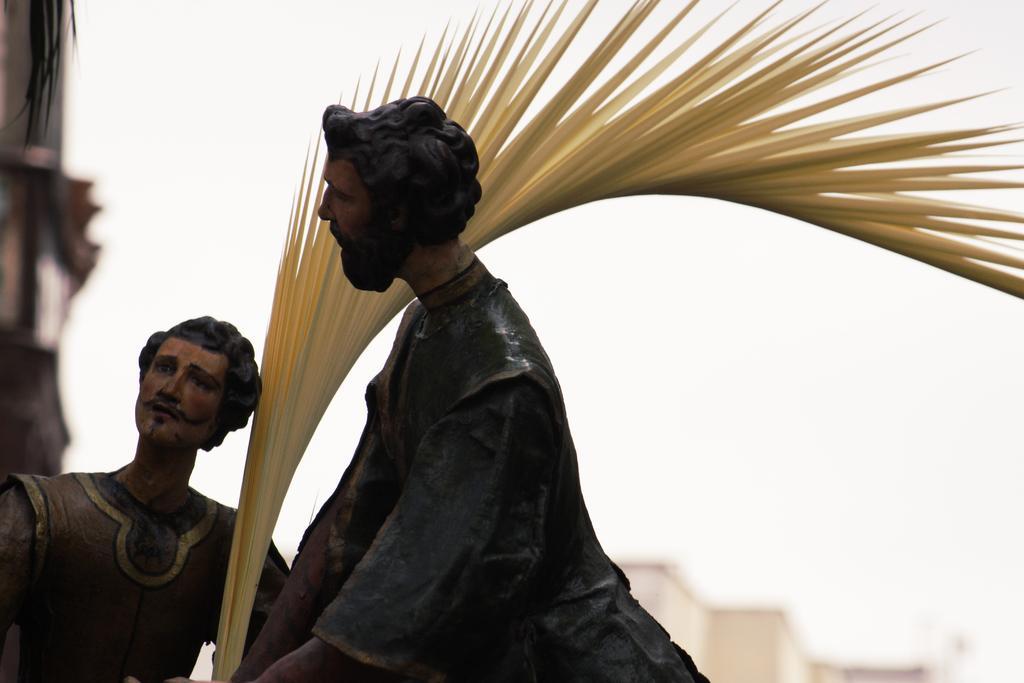Can you describe this image briefly? In this image I can see two mini sculptures of men. I can also see a yellow colour thing over here and I can see this image is blurry from background. I can also see white color in the background. 